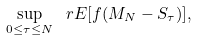Convert formula to latex. <formula><loc_0><loc_0><loc_500><loc_500>\sup _ { 0 \leq \tau \leq N } \ r E [ f ( M _ { N } - S _ { \tau } ) ] ,</formula> 